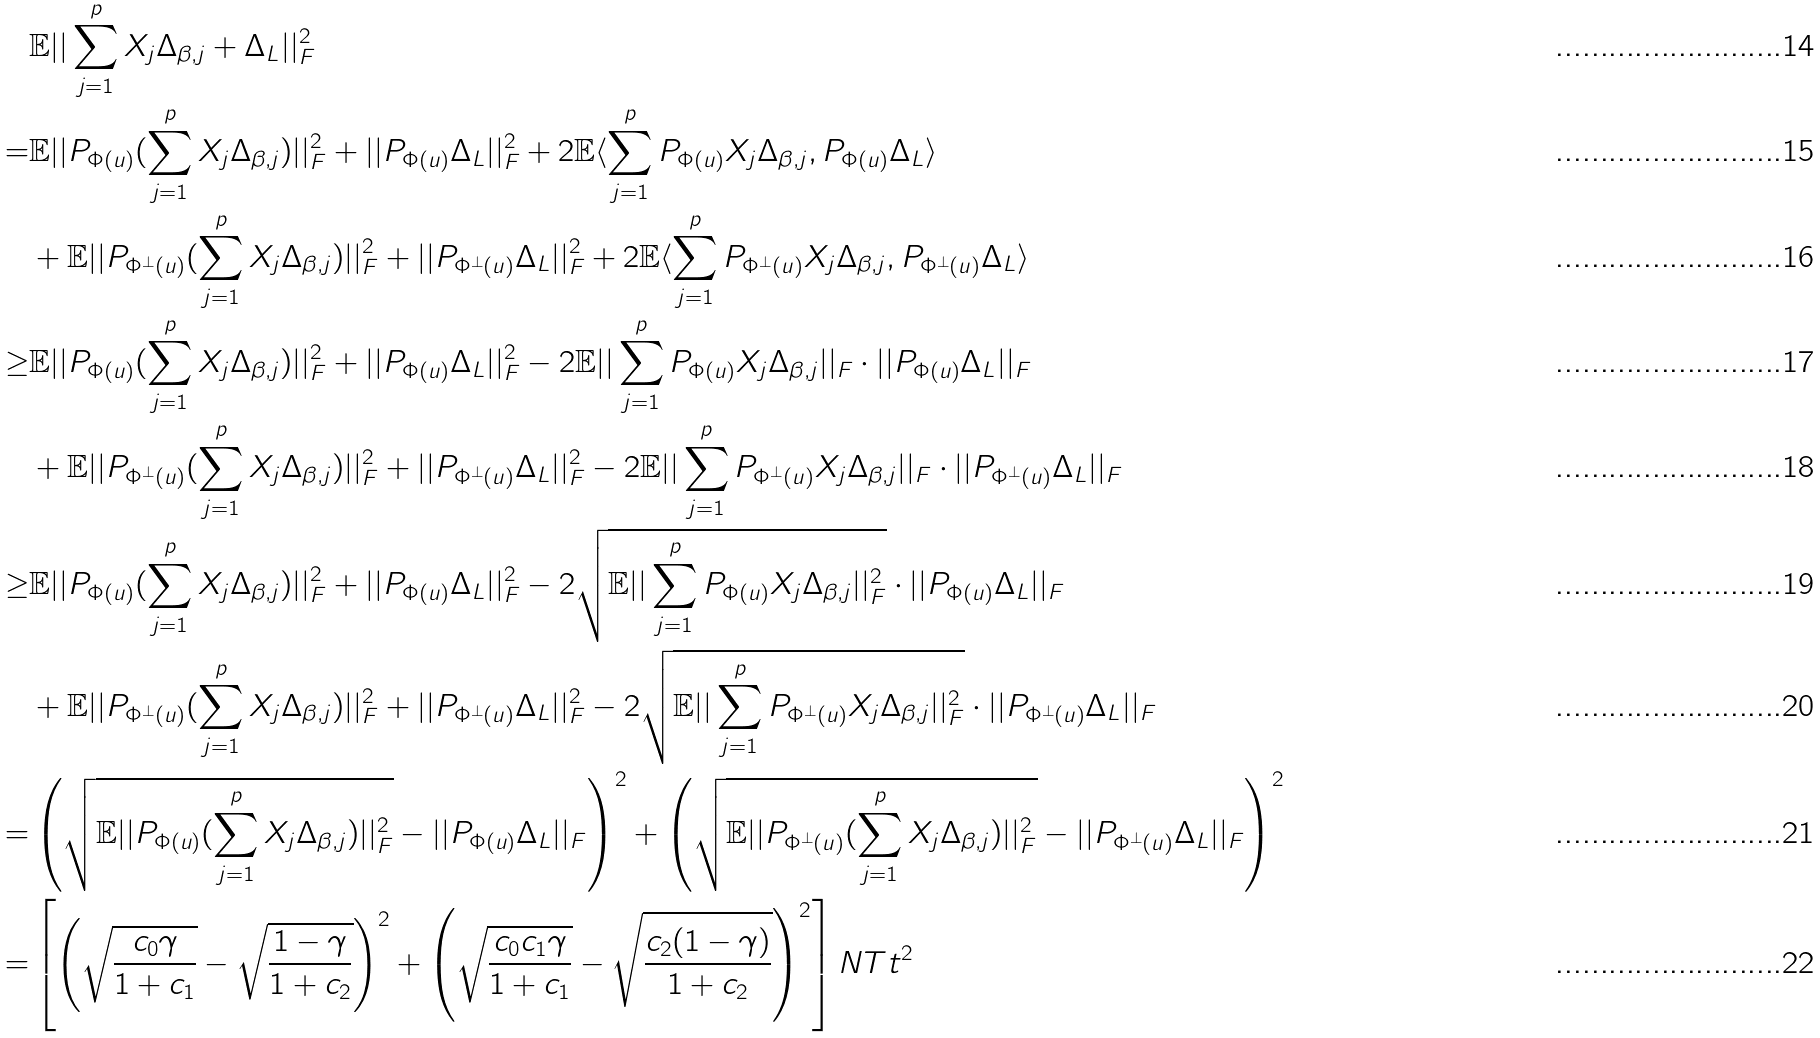<formula> <loc_0><loc_0><loc_500><loc_500>& \mathbb { E } | | \sum _ { j = 1 } ^ { p } X _ { j } \Delta _ { \beta , j } + \Delta _ { L } | | _ { F } ^ { 2 } \\ = & \mathbb { E } | | P _ { \Phi ( u ) } ( \sum _ { j = 1 } ^ { p } X _ { j } \Delta _ { \beta , j } ) | | _ { F } ^ { 2 } + | | P _ { \Phi ( u ) } \Delta _ { L } | | _ { F } ^ { 2 } + 2 \mathbb { E } \langle \sum _ { j = 1 } ^ { p } P _ { \Phi ( u ) } X _ { j } \Delta _ { \beta , j } , P _ { \Phi ( u ) } \Delta _ { L } \rangle \\ & + \mathbb { E } | | P _ { \Phi ^ { \perp } ( u ) } ( \sum _ { j = 1 } ^ { p } X _ { j } \Delta _ { \beta , j } ) | | _ { F } ^ { 2 } + | | P _ { \Phi ^ { \perp } ( u ) } \Delta _ { L } | | _ { F } ^ { 2 } + 2 \mathbb { E } \langle \sum _ { j = 1 } ^ { p } P _ { \Phi ^ { \perp } ( u ) } X _ { j } \Delta _ { \beta , j } , P _ { \Phi ^ { \perp } ( u ) } \Delta _ { L } \rangle \\ \geq & \mathbb { E } | | P _ { \Phi ( u ) } ( \sum _ { j = 1 } ^ { p } X _ { j } \Delta _ { \beta , j } ) | | _ { F } ^ { 2 } + | | P _ { \Phi ( u ) } \Delta _ { L } | | _ { F } ^ { 2 } - 2 \mathbb { E } | | \sum _ { j = 1 } ^ { p } P _ { \Phi ( u ) } X _ { j } \Delta _ { \beta , j } | | _ { F } \cdot | | P _ { \Phi ( u ) } \Delta _ { L } | | _ { F } \\ & + \mathbb { E } | | P _ { \Phi ^ { \perp } ( u ) } ( \sum _ { j = 1 } ^ { p } X _ { j } \Delta _ { \beta , j } ) | | _ { F } ^ { 2 } + | | P _ { \Phi ^ { \perp } ( u ) } \Delta _ { L } | | _ { F } ^ { 2 } - 2 \mathbb { E } | | \sum _ { j = 1 } ^ { p } P _ { \Phi ^ { \perp } ( u ) } X _ { j } \Delta _ { \beta , j } | | _ { F } \cdot | | P _ { \Phi ^ { \perp } ( u ) } \Delta _ { L } | | _ { F } \\ \geq & \mathbb { E } | | P _ { \Phi ( u ) } ( \sum _ { j = 1 } ^ { p } X _ { j } \Delta _ { \beta , j } ) | | _ { F } ^ { 2 } + | | P _ { \Phi ( u ) } \Delta _ { L } | | _ { F } ^ { 2 } - 2 \sqrt { \mathbb { E } | | \sum _ { j = 1 } ^ { p } P _ { \Phi ( u ) } X _ { j } \Delta _ { \beta , j } | | _ { F } ^ { 2 } } \cdot | | P _ { \Phi ( u ) } \Delta _ { L } | | _ { F } \\ & + \mathbb { E } | | P _ { \Phi ^ { \perp } ( u ) } ( \sum _ { j = 1 } ^ { p } X _ { j } \Delta _ { \beta , j } ) | | _ { F } ^ { 2 } + | | P _ { \Phi ^ { \perp } ( u ) } \Delta _ { L } | | _ { F } ^ { 2 } - 2 \sqrt { \mathbb { E } | | \sum _ { j = 1 } ^ { p } P _ { \Phi ^ { \perp } ( u ) } X _ { j } \Delta _ { \beta , j } | | _ { F } ^ { 2 } } \cdot | | P _ { \Phi ^ { \perp } ( u ) } \Delta _ { L } | | _ { F } \\ = & \left ( \sqrt { \mathbb { E } | | P _ { \Phi ( u ) } ( \sum _ { j = 1 } ^ { p } X _ { j } \Delta _ { \beta , j } ) | | _ { F } ^ { 2 } } - | | P _ { \Phi ( u ) } \Delta _ { L } | | _ { F } \right ) ^ { 2 } + \left ( \sqrt { \mathbb { E } | | P _ { \Phi ^ { \perp } ( u ) } ( \sum _ { j = 1 } ^ { p } X _ { j } \Delta _ { \beta , j } ) | | _ { F } ^ { 2 } } - | | P _ { \Phi ^ { \perp } ( u ) } \Delta _ { L } | | _ { F } \right ) ^ { 2 } \\ = & \left [ \left ( \sqrt { \frac { c _ { 0 } \gamma } { 1 + c _ { 1 } } } - \sqrt { \frac { 1 - \gamma } { 1 + c _ { 2 } } } \right ) ^ { 2 } + \left ( \sqrt { \frac { c _ { 0 } c _ { 1 } \gamma } { 1 + c _ { 1 } } } - \sqrt { \frac { c _ { 2 } ( 1 - \gamma ) } { 1 + c _ { 2 } } } \right ) ^ { 2 } \right ] N T t ^ { 2 }</formula> 